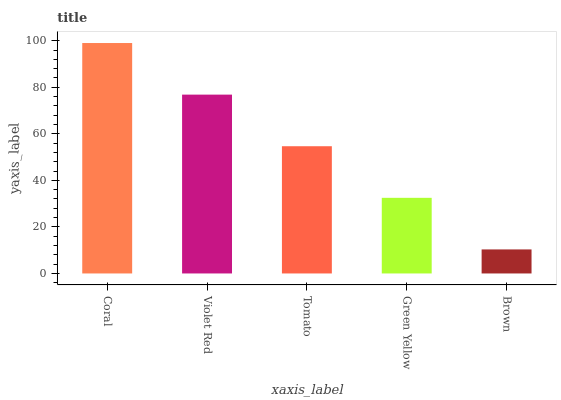Is Brown the minimum?
Answer yes or no. Yes. Is Coral the maximum?
Answer yes or no. Yes. Is Violet Red the minimum?
Answer yes or no. No. Is Violet Red the maximum?
Answer yes or no. No. Is Coral greater than Violet Red?
Answer yes or no. Yes. Is Violet Red less than Coral?
Answer yes or no. Yes. Is Violet Red greater than Coral?
Answer yes or no. No. Is Coral less than Violet Red?
Answer yes or no. No. Is Tomato the high median?
Answer yes or no. Yes. Is Tomato the low median?
Answer yes or no. Yes. Is Coral the high median?
Answer yes or no. No. Is Coral the low median?
Answer yes or no. No. 